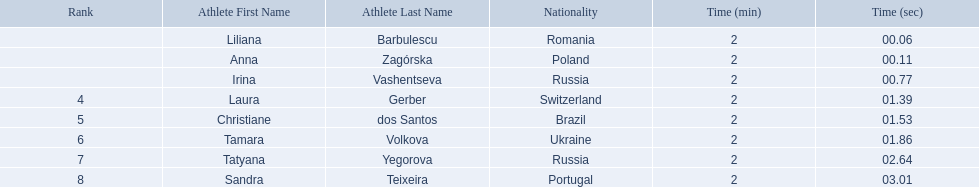Who were the athlete were in the athletics at the 2003 summer universiade - women's 800 metres? , Liliana Barbulescu, Anna Zagórska, Irina Vashentseva, Laura Gerber, Christiane dos Santos, Tamara Volkova, Tatyana Yegorova, Sandra Teixeira. What was anna zagorska finishing time? 2:00.11. 